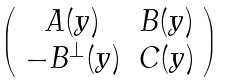Convert formula to latex. <formula><loc_0><loc_0><loc_500><loc_500>\left ( \begin{array} { c c } A ( y ) & B ( y ) \\ - B ^ { \perp } ( y ) & C ( y ) \\ \end{array} \right )</formula> 